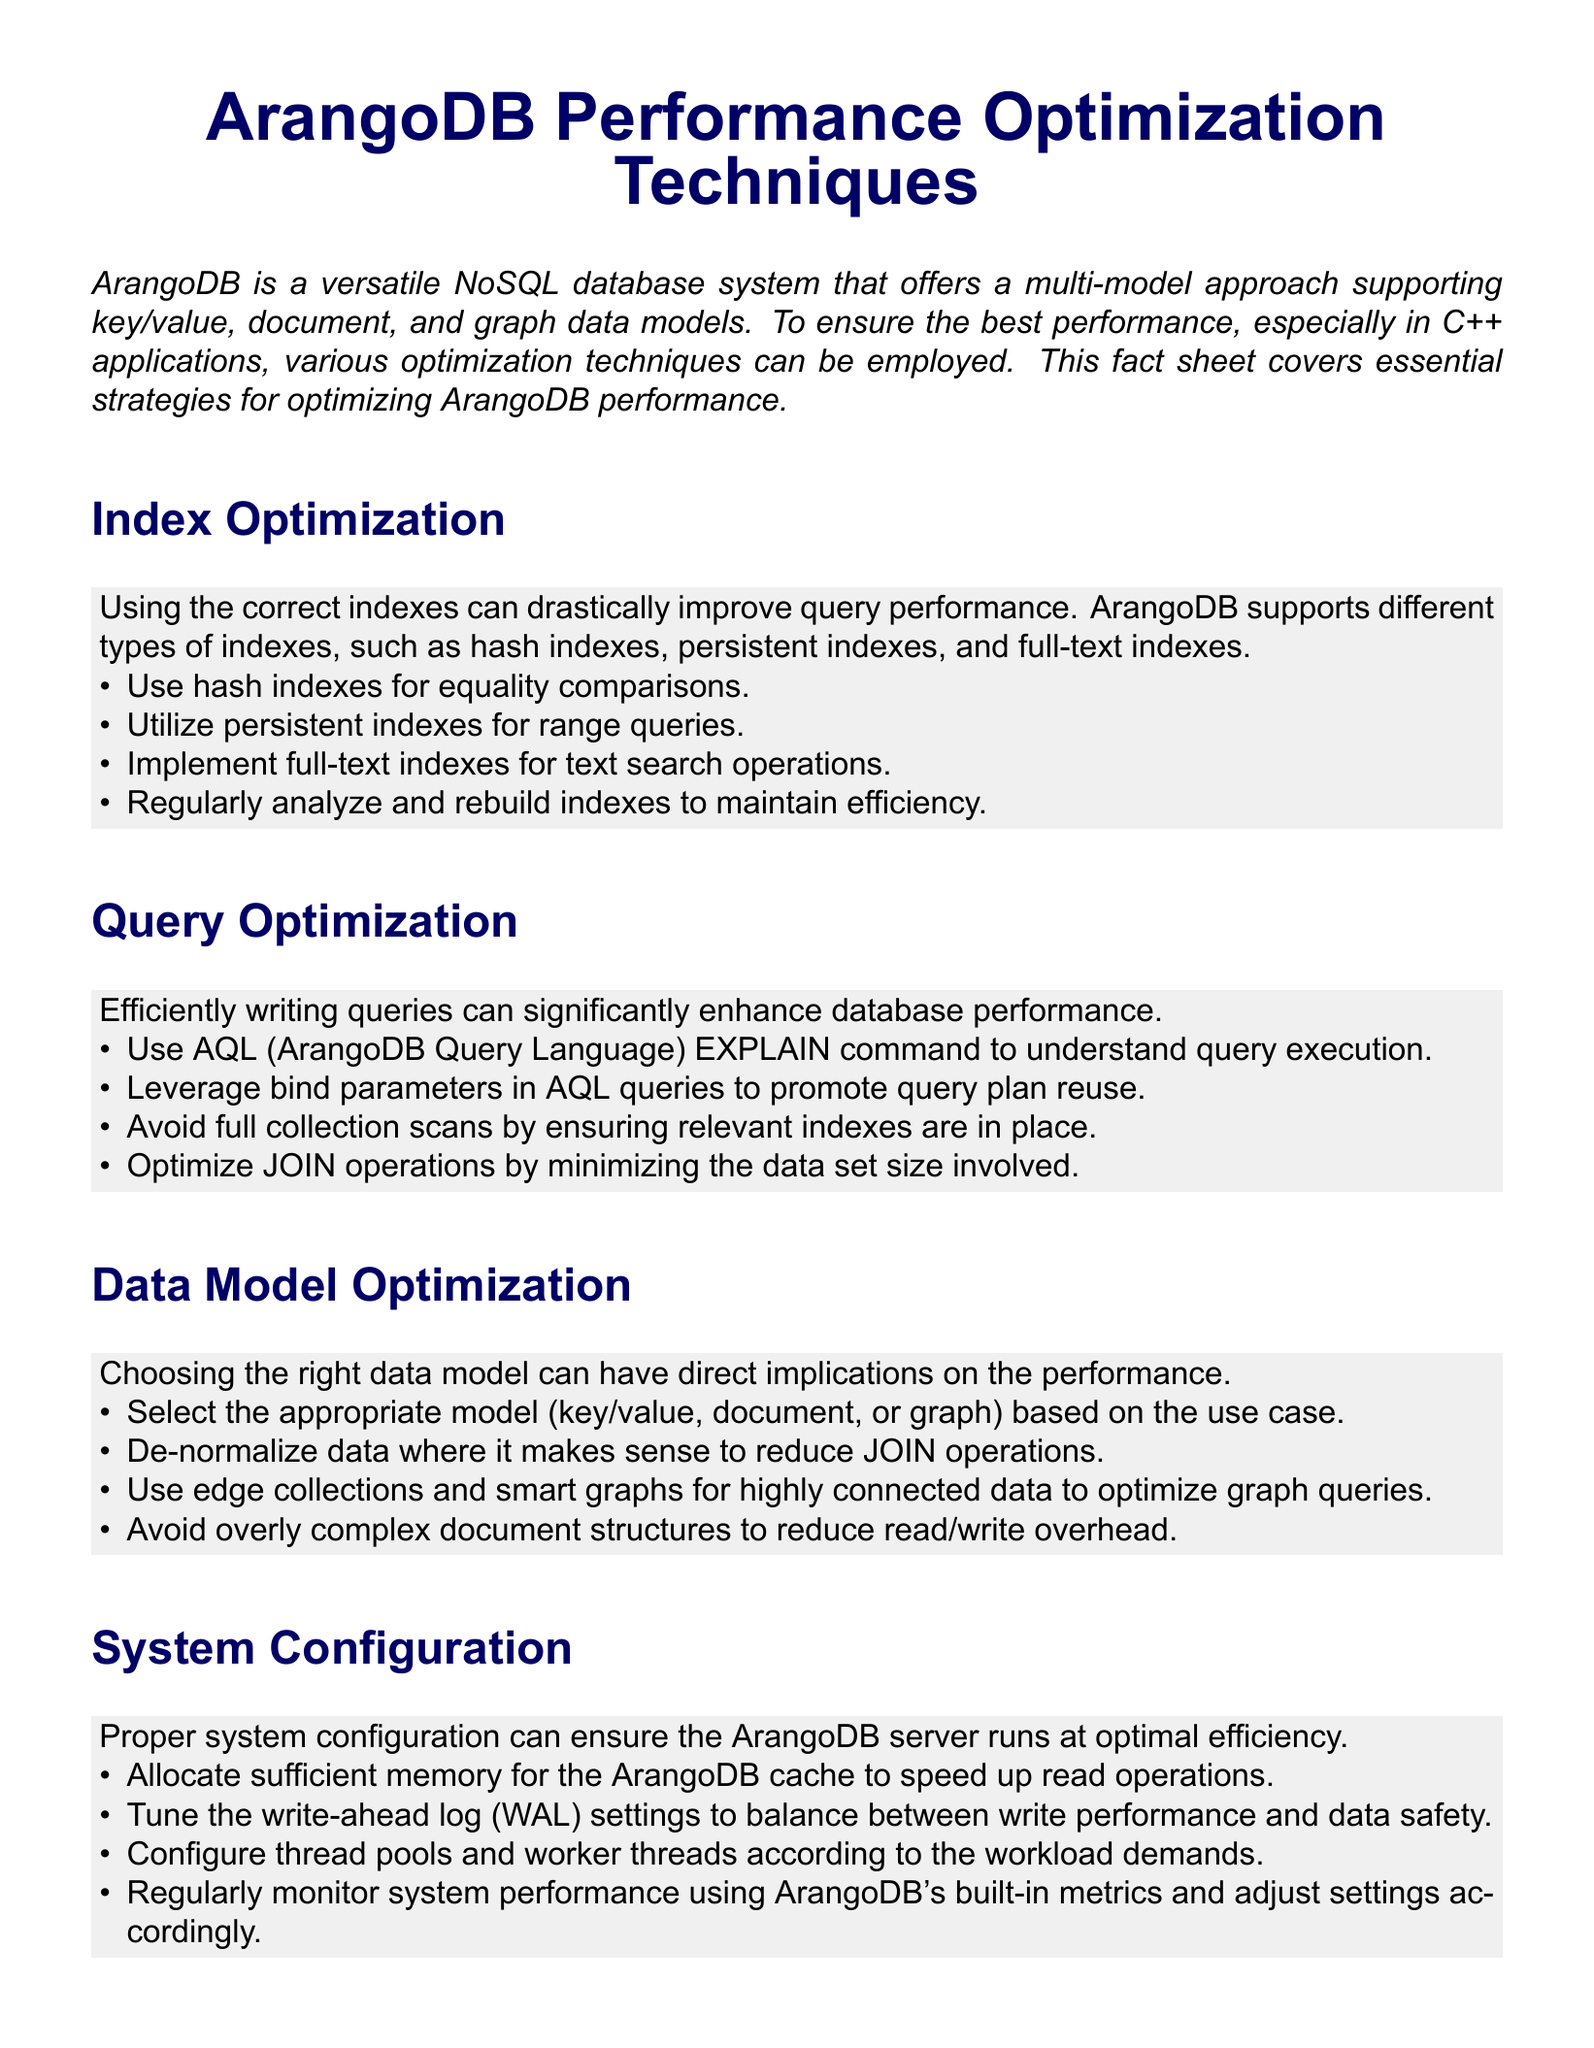What types of indexes does ArangoDB support? The document outlines several index types applicable in ArangoDB, including hash indexes, persistent indexes, and full-text indexes.
Answer: hash indexes, persistent indexes, full-text indexes What command helps understand query execution in ArangoDB? The document mentions the AQL (ArangoDB Query Language) EXPLAIN command as a tool for understanding how queries are executed.
Answer: EXPLAIN What should be avoided to prevent unnecessary database scans? The document advises ensuring relevant indexes are in place to avoid full collection scans during query operations.
Answer: full collection scans What technique can reduce JOIN operations when modeling data? De-normalizing data is highlighted in the document as a technique that can help reduce the number of JOIN operations required.
Answer: De-normalize data What optimization can be performed on ArangoDB's write-ahead log? The document suggests tuning the WAL (write-ahead log) settings to achieve a balance between write performance and data safety.
Answer: WAL settings What storage solution is recommended for improving I/O operations? Using SSDs for storage is recommended in the document to enhance the performance of I/O operations.
Answer: SSDs What is one hardware scaling strategy mentioned for ArangoDB? The document suggests scaling horizontally using ArangoDB's native sharding and clustering capabilities as a strategy.
Answer: sharding and clustering How often should indexes be analyzed and rebuilt? The document encourages regular analysis and rebuilding of indexes to maintain efficiency without specifying exact intervals.
Answer: Regularly What is the primary focus of this fact sheet? The fact sheet is centered around strategies and techniques for optimizing performance specifically in ArangoDB.
Answer: performance optimization techniques 